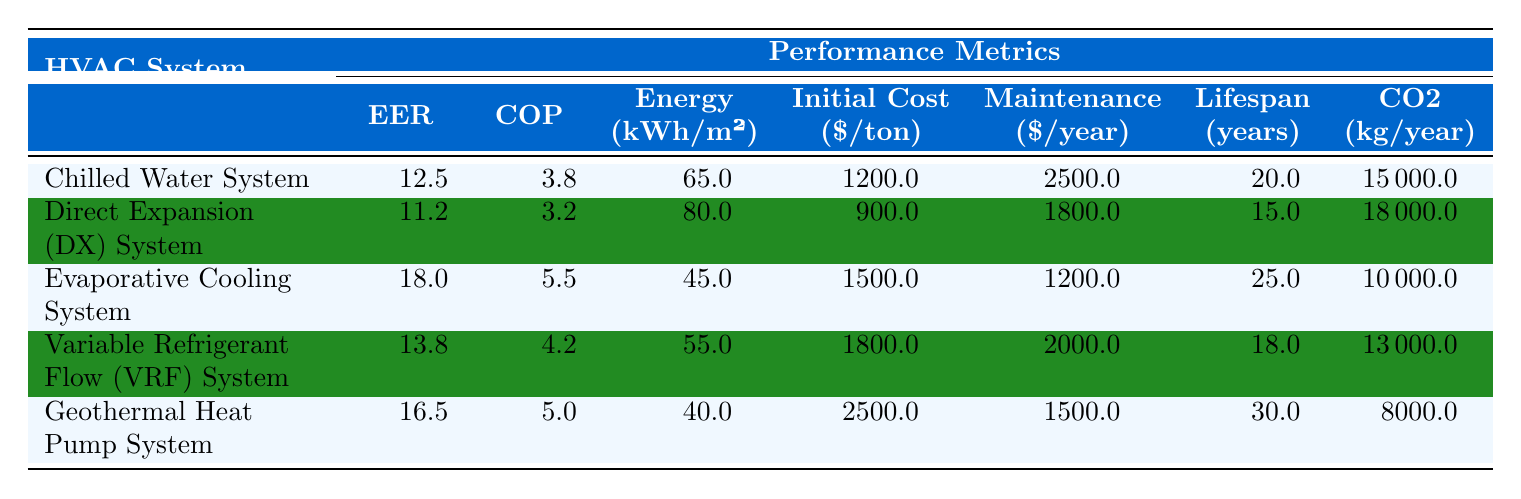What is the Energy Efficiency Ratio (EER) of the Evaporative Cooling System? The EER for the Evaporative Cooling System is listed in the table as 18.0.
Answer: 18.0 Which HVAC system has the lowest Annual Energy Consumption? The system with the lowest Annual Energy Consumption is the Geothermal Heat Pump System with 40 kWh/m².
Answer: Geothermal Heat Pump System What is the average lifespan of all the HVAC systems listed? To find the average lifespan, add the lifespans: (20 + 15 + 25 + 18 + 30) = 108, then divide by the number of systems (5), which gives 108/5 = 21.6 years.
Answer: 21.6 years Does the Chilled Water System have a higher Coefficient of Performance (COP) than the Direct Expansion (DX) System? The COP of the Chilled Water System is 3.8, and the COP of the Direct Expansion (DX) System is 3.2. Since 3.8 > 3.2, the statement is true.
Answer: Yes What is the difference in Initial Cost between the highest and lowest priced HVAC systems? The highest Initial Cost is for the Geothermal Heat Pump System at $2500/ton and the lowest is for the Direct Expansion (DX) System at $900/ton. Thus, the difference is $2500 - $900 = $1600.
Answer: $1600 Which system emits the most CO2 per year? The system with the highest CO2 emissions is the Direct Expansion (DX) System, which emits 18000 kg/year.
Answer: Direct Expansion (DX) System If you combine the Energy Efficiency Ratios (EER) of the Chilled Water System and Variable Refrigerant Flow (VRF) System, what would it be? The EER for the Chilled Water System is 12.5 and for the VRF System is 13.8. Combining these gives 12.5 + 13.8 = 26.3.
Answer: 26.3 Is it true that the Evaporative Cooling System has a lower maintenance cost than the Variable Refrigerant Flow (VRF) System? The maintenance cost for the Evaporative Cooling System is $1200/year, while for the VRF System, it is $2000/year. Since $1200 < $2000, the statement is true.
Answer: Yes What metric shows that the Geothermal Heat Pump System is the most efficient in terms of lifespan compared to the others? The Geothermal Heat Pump System has the highest lifespan at 30 years, which is greater than all other HVAC systems listed (Chilled Water: 20, DX: 15, Evaporative: 25, VRF: 18).
Answer: 30 years Which system offers the best average performance based on EER and COP combined? The average performance can be determined by adding the EER and COP for each system: Chilled Water System (12.5 + 3.8), DX System (11.2 + 3.2), Evaporative System (18.0 + 5.5), VRF System (13.8 + 4.2), and Geothermal System (16.5 + 5.0). The highest average of EER + COP is 23.5 for the Evaporative Cooling System.
Answer: Evaporative Cooling System 